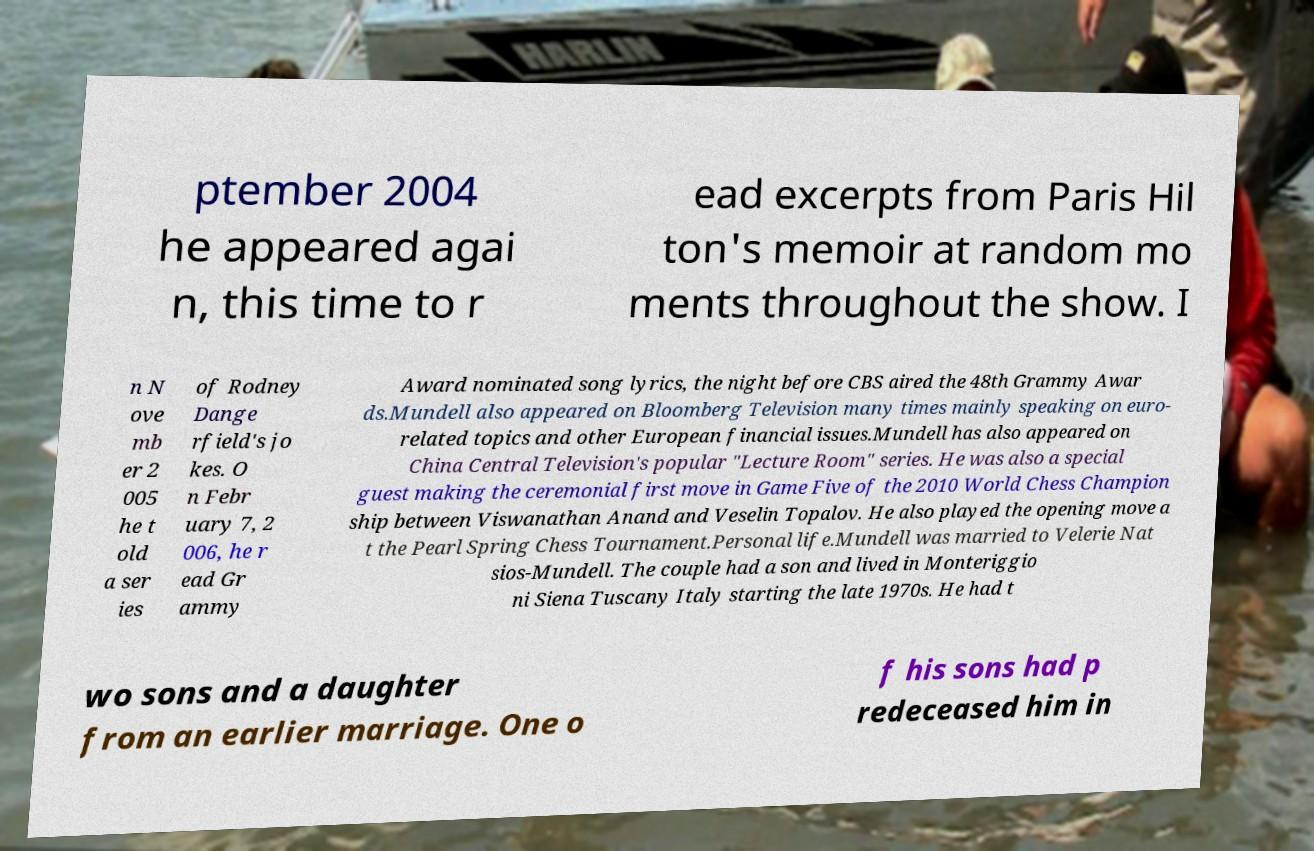Can you read and provide the text displayed in the image?This photo seems to have some interesting text. Can you extract and type it out for me? ptember 2004 he appeared agai n, this time to r ead excerpts from Paris Hil ton's memoir at random mo ments throughout the show. I n N ove mb er 2 005 he t old a ser ies of Rodney Dange rfield's jo kes. O n Febr uary 7, 2 006, he r ead Gr ammy Award nominated song lyrics, the night before CBS aired the 48th Grammy Awar ds.Mundell also appeared on Bloomberg Television many times mainly speaking on euro- related topics and other European financial issues.Mundell has also appeared on China Central Television's popular "Lecture Room" series. He was also a special guest making the ceremonial first move in Game Five of the 2010 World Chess Champion ship between Viswanathan Anand and Veselin Topalov. He also played the opening move a t the Pearl Spring Chess Tournament.Personal life.Mundell was married to Velerie Nat sios-Mundell. The couple had a son and lived in Monteriggio ni Siena Tuscany Italy starting the late 1970s. He had t wo sons and a daughter from an earlier marriage. One o f his sons had p redeceased him in 